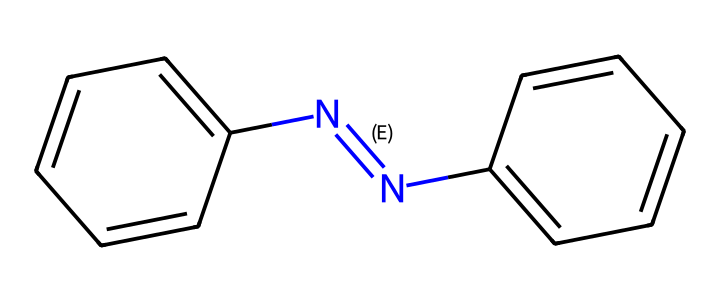What is the molecular formula of azobenzene? The molecular formula can be derived from the compound structure represented in SMILES. The structure consists of two benzene rings and a nitrogen-nitrogen double bond, leading to the molecular formula C12H10N2.
Answer: C12H10N2 How many π bonds are present in azobenzene? Analyzing the structure reveals that there are two double bonds in the azobenzene's nitrogen-nitrogen linkage, and each benzene ring has three double bonds. This results in a total of 5 π bonds.
Answer: 5 Does azobenzene exhibit E-Z isomerism? Given the presence of the nitrogen-nitrogen double bond (N=N) between the two aromatic rings, azobenzene has geometric isomerism due to the restricted rotation around the N=N bond, allowing for E (trans) and Z (cis) isomers.
Answer: Yes What is the significance of the E-Z isomerism in azobenzene for its applications? The E-Z isomerism in azobenzene allows it to undergo reversible photoisomerization, making it important in applications like smart materials and drug delivery, where the change in isomer can trigger different physical properties or functions.
Answer: Reversible photoisomerization How many stereoisomers can azobenzene have? Azobenzene has two geometric isomers (E and Z). Since there are no other chiral centers in the molecule, it can only exist as these two forms.
Answer: 2 In the E isomer of azobenzene, how are the phenyl groups oriented relative to each other? In the E isomer, the two phenyl groups are positioned opposite each other, creating a trans configuration across the nitrogen-nitrogen bond.
Answer: Opposite 